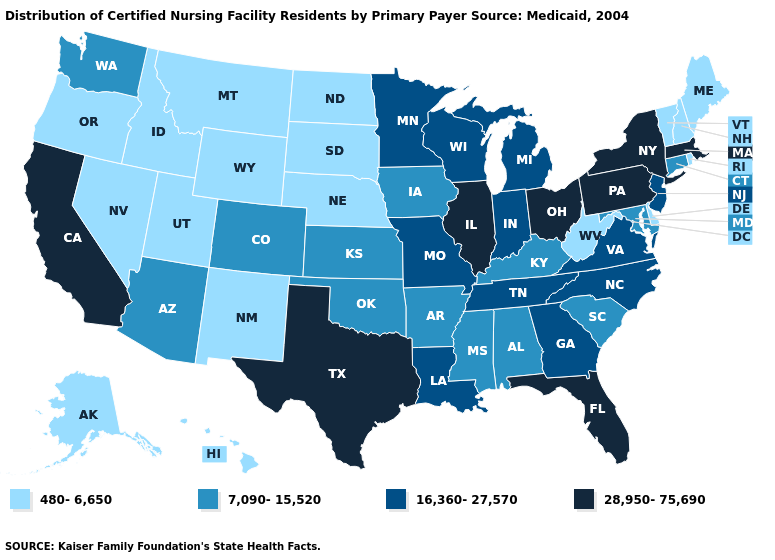Name the states that have a value in the range 7,090-15,520?
Short answer required. Alabama, Arizona, Arkansas, Colorado, Connecticut, Iowa, Kansas, Kentucky, Maryland, Mississippi, Oklahoma, South Carolina, Washington. What is the value of New Hampshire?
Be succinct. 480-6,650. Does the map have missing data?
Answer briefly. No. What is the value of Alaska?
Keep it brief. 480-6,650. What is the value of Illinois?
Answer briefly. 28,950-75,690. What is the lowest value in the USA?
Short answer required. 480-6,650. Name the states that have a value in the range 480-6,650?
Quick response, please. Alaska, Delaware, Hawaii, Idaho, Maine, Montana, Nebraska, Nevada, New Hampshire, New Mexico, North Dakota, Oregon, Rhode Island, South Dakota, Utah, Vermont, West Virginia, Wyoming. What is the highest value in the USA?
Give a very brief answer. 28,950-75,690. What is the value of Washington?
Quick response, please. 7,090-15,520. Which states have the lowest value in the USA?
Keep it brief. Alaska, Delaware, Hawaii, Idaho, Maine, Montana, Nebraska, Nevada, New Hampshire, New Mexico, North Dakota, Oregon, Rhode Island, South Dakota, Utah, Vermont, West Virginia, Wyoming. How many symbols are there in the legend?
Concise answer only. 4. What is the lowest value in states that border Alabama?
Short answer required. 7,090-15,520. Name the states that have a value in the range 16,360-27,570?
Write a very short answer. Georgia, Indiana, Louisiana, Michigan, Minnesota, Missouri, New Jersey, North Carolina, Tennessee, Virginia, Wisconsin. What is the lowest value in the MidWest?
Short answer required. 480-6,650. Does the first symbol in the legend represent the smallest category?
Give a very brief answer. Yes. 